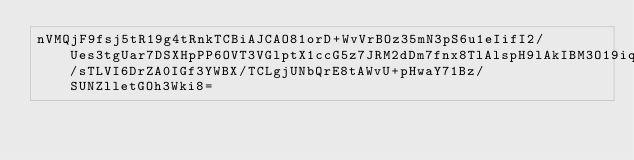Convert code to text. <code><loc_0><loc_0><loc_500><loc_500><_SML_>nVMQjF9fsj5tR19g4tRnkTCBiAJCAO81orD+WvVrBOz35mN3pS6u1eIifI2/Ues3tgUar7DSXHpPP6OVT3VGlptX1ccG5z7JRM2dDm7fnx8TlAlspH9lAkIBM3O19iq57GK1b8j7zJr359/sTLVI6DrZA0IGf3YWBX/TCLgjUNbQrE8tAWvU+pHwaY71Bz/SUNZlletGOh3Wki8=</code> 